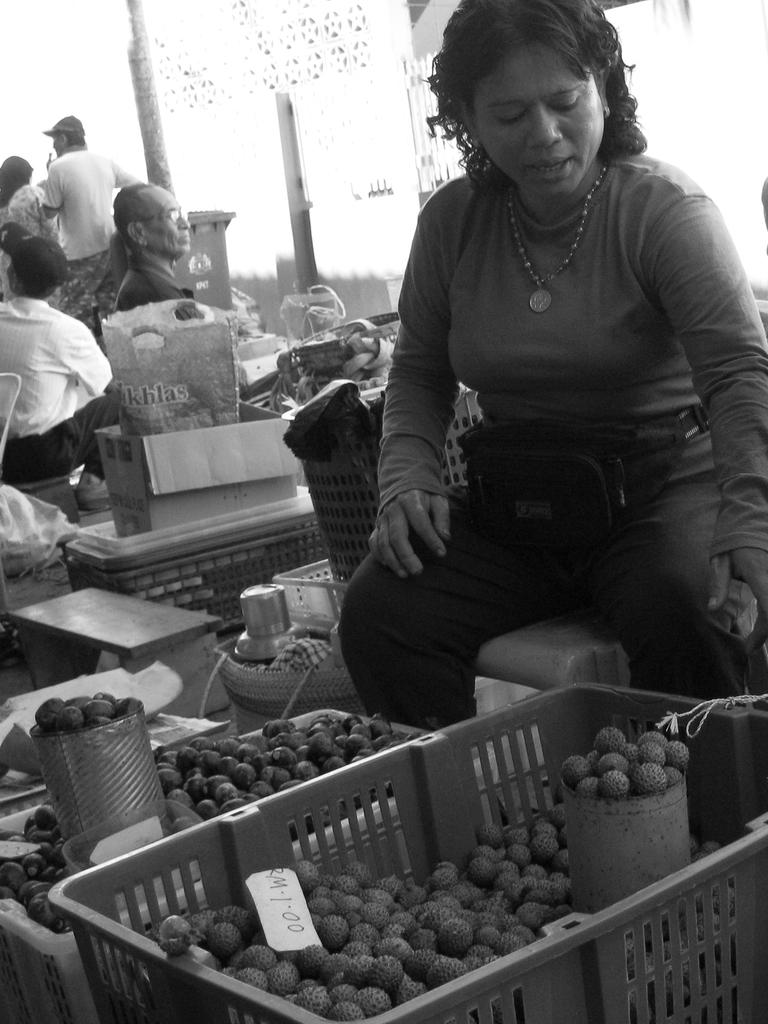What type of food can be seen in the image? There are fruits in boxes in the image. Where are the fruits located in the image? The fruits are located at the bottom of the image. Can you describe the woman in the image? There is a woman sitting on the right side of the image. How many people are on the left side of the image? There are a few persons on the left side of the image. What type of jam is being spread on the boundary in the image? There is no jam or boundary present in the image; it features fruits in boxes, a woman sitting on the right side, and a few persons on the left side. 